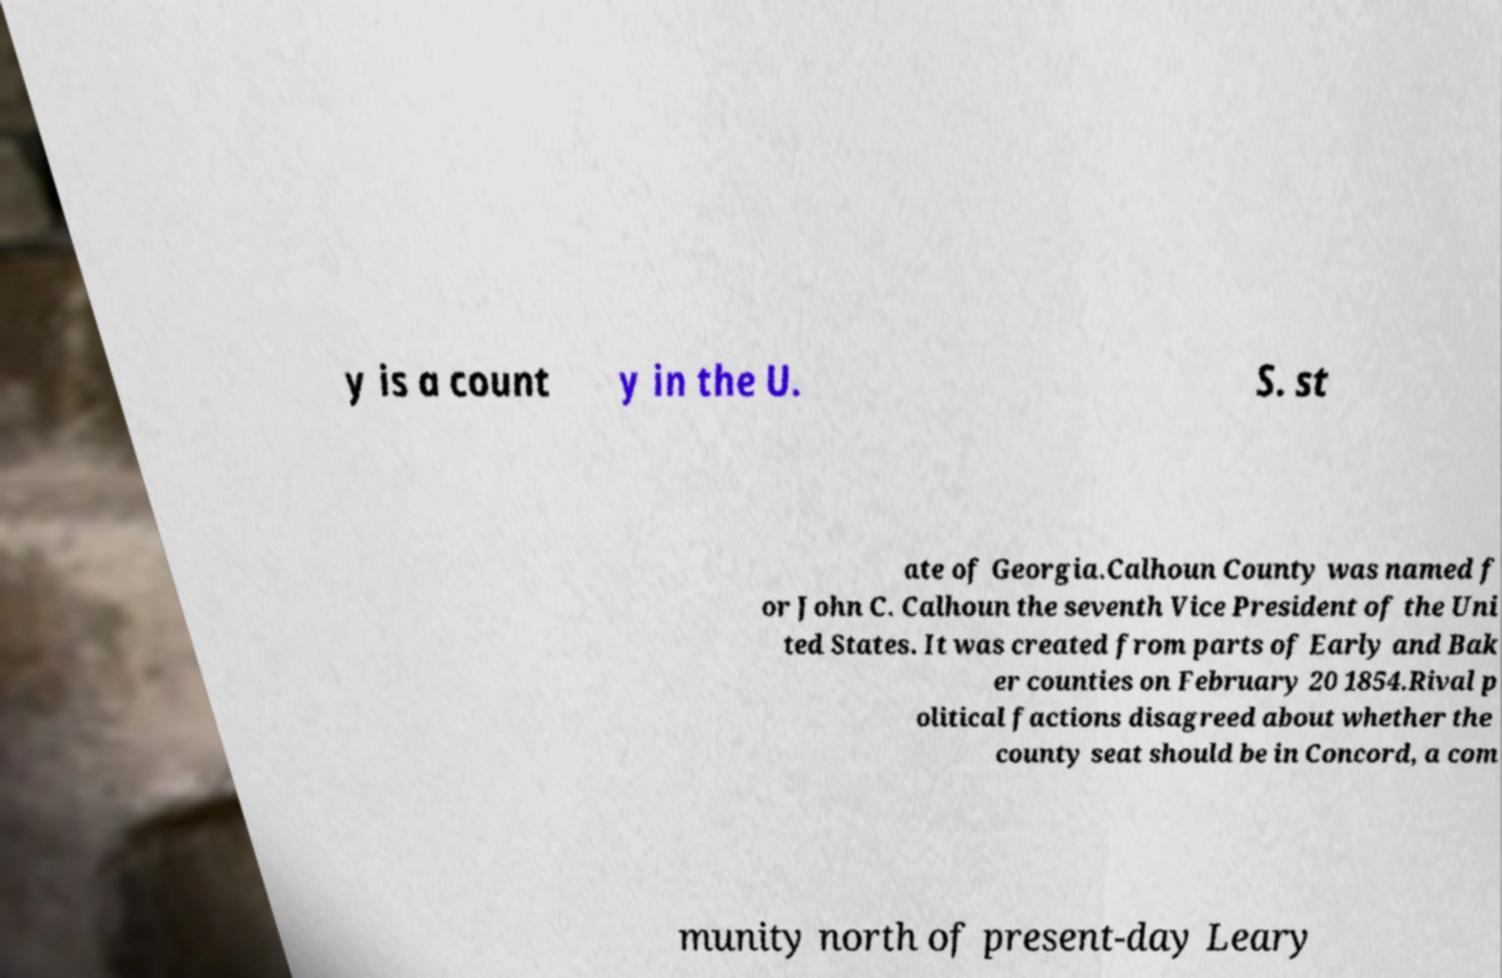Could you assist in decoding the text presented in this image and type it out clearly? y is a count y in the U. S. st ate of Georgia.Calhoun County was named f or John C. Calhoun the seventh Vice President of the Uni ted States. It was created from parts of Early and Bak er counties on February 20 1854.Rival p olitical factions disagreed about whether the county seat should be in Concord, a com munity north of present-day Leary 